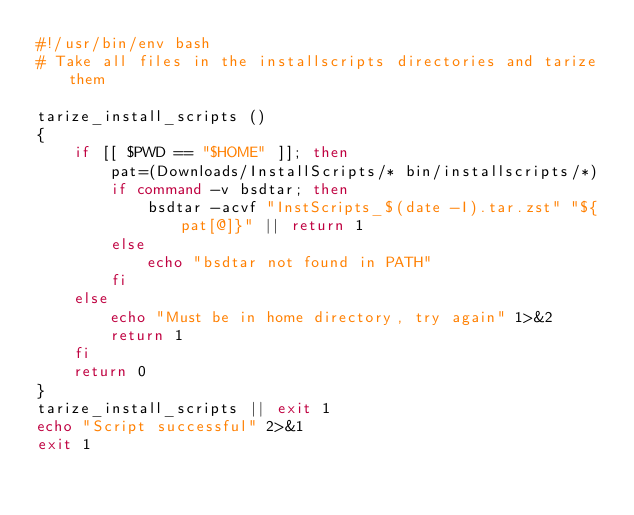Convert code to text. <code><loc_0><loc_0><loc_500><loc_500><_Bash_>#!/usr/bin/env bash
# Take all files in the installscripts directories and tarize them

tarize_install_scripts () 
{ 
    if [[ $PWD == "$HOME" ]]; then
        pat=(Downloads/InstallScripts/* bin/installscripts/*)
        if command -v bsdtar; then
            bsdtar -acvf "InstScripts_$(date -I).tar.zst" "${pat[@]}" || return 1
        else
            echo "bsdtar not found in PATH"
        fi
    else
        echo "Must be in home directory, try again" 1>&2
        return 1
    fi
    return 0
}
tarize_install_scripts || exit 1
echo "Script successful" 2>&1
exit 1
</code> 